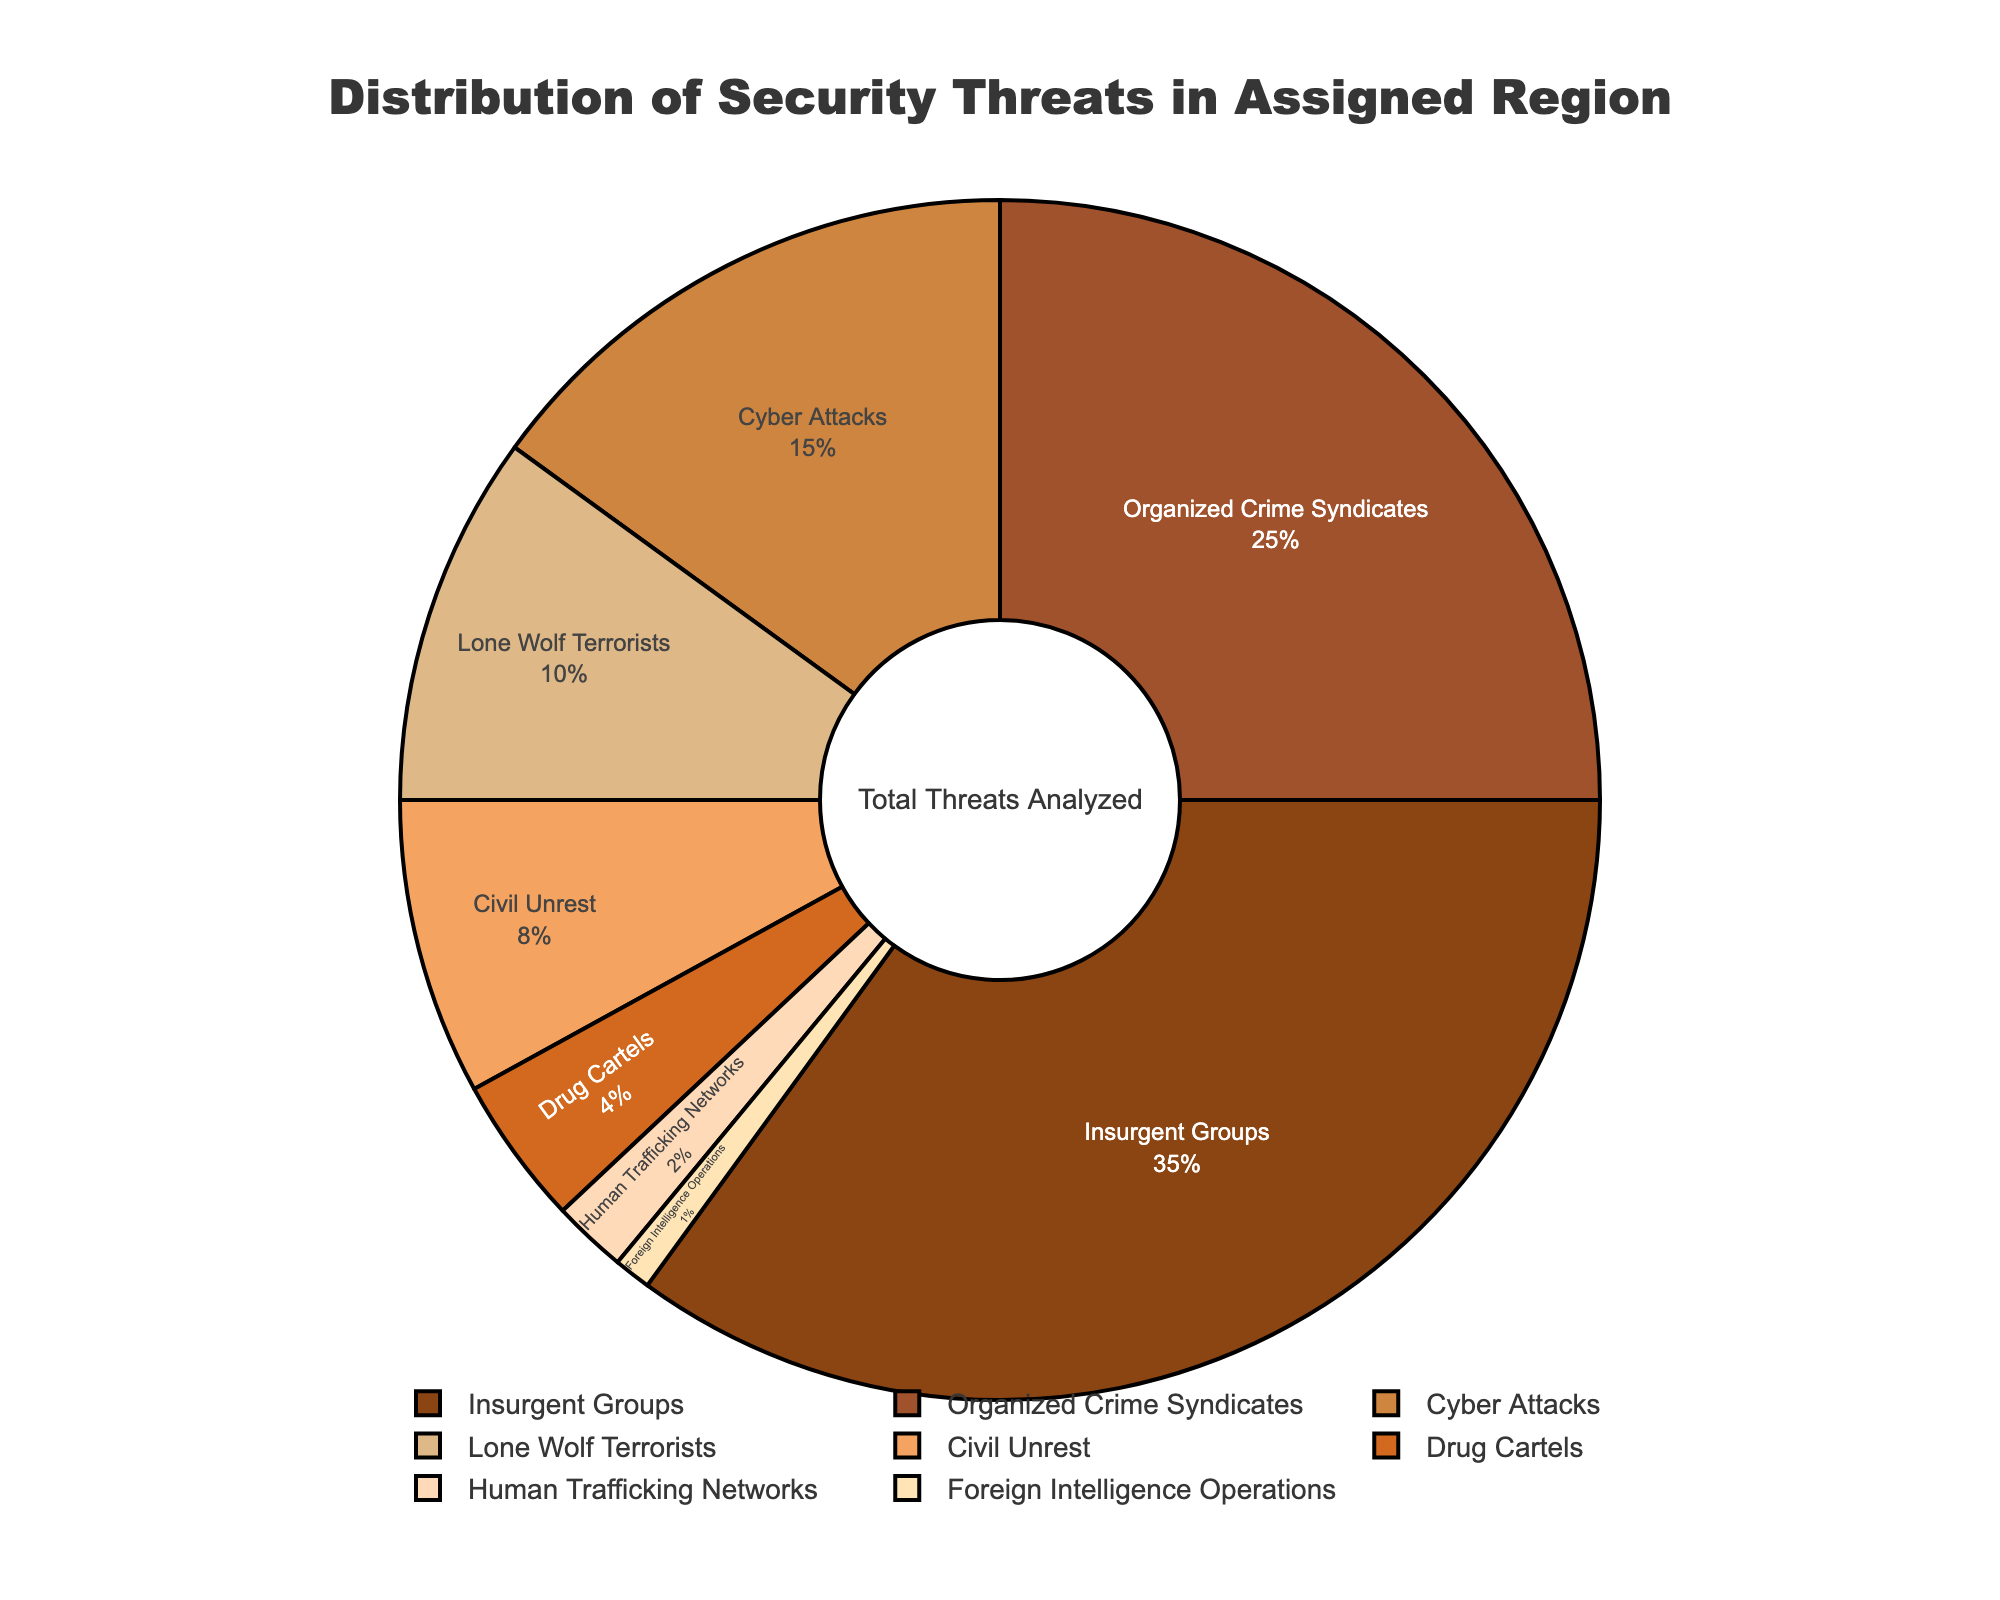What is the most common threat type in the assigned region? The slice labeled "Insurgent Groups" occupies the largest portion of the pie chart, representing 35% of the total threats.
Answer: Insurgent Groups What is the combined percentage of Insurgent Groups and Organized Crime Syndicates? Adding the percentages for Insurgent Groups (35%) and Organized Crime Syndicates (25%) gives a total of 35% + 25% = 60%.
Answer: 60% Which threat type has the least presence in the region? The slice labeled "Foreign Intelligence Operations" occupies the smallest portion of the pie chart, representing 1% of the total threats.
Answer: Foreign Intelligence Operations How does the percentage of Cyber Attacks compare to Lone Wolf Terrorists? Cyber Attacks represent 15% of total threats, while Lone Wolf Terrorists constitute 10%. Thus, Cyber Attacks are more prevalent by a difference of 5%.
Answer: Cyber Attacks are more prevalent by 5% What is the total percentage of threats related to drug-related activities (Organized Crime Syndicates and Drug Cartels)? Adding the percentages for Organized Crime Syndicates (25%) and Drug Cartels (4%) gives a total of 25% + 4% = 29%.
Answer: 29% What percentage is covered by the threats labeled in lighter shades of brown? The lighter shades of brown are used for the "Drug Cartels," "Human Trafficking Networks," and "Foreign Intelligence Operations" slices. Summing their percentages: 4% + 2% + 1% = 7%.
Answer: 7% Which two threat types together account for nearly half of all threats in the region? The combined percentages of Insurgent Groups (35%) and Organized Crime Syndicates (25%) is 60%, which is well above half. However, combining Insurgent Groups (35%) and Cyber Attacks (15%) gives exactly 50%.
Answer: Insurgent Groups and Cyber Attacks How much larger in percentage is Civil Unrest compared to Human Trafficking Networks? Civil Unrest accounts for 8% of total threats, while Human Trafficking Networks account for 2%. The difference is 8% - 2% = 6%.
Answer: 6% What is the difference in percentage between the top three threat types and the sum of the other threats? The top three threat types are Insurgent Groups (35%), Organized Crime Syndicates (25%), and Cyber Attacks (15%), summing to 35% + 25% + 15% = 75%. The sum of the other threat types is 100% - 75% = 25%.
Answer: 50% What is the total percentage of threats formed by Lone Wolf Terrorists, Civil Unrest, and Drug Cartels? Summing the percentages for Lone Wolf Terrorists (10%), Civil Unrest (8%), and Drug Cartels (4%) gives 10% + 8% + 4% = 22%.
Answer: 22% 